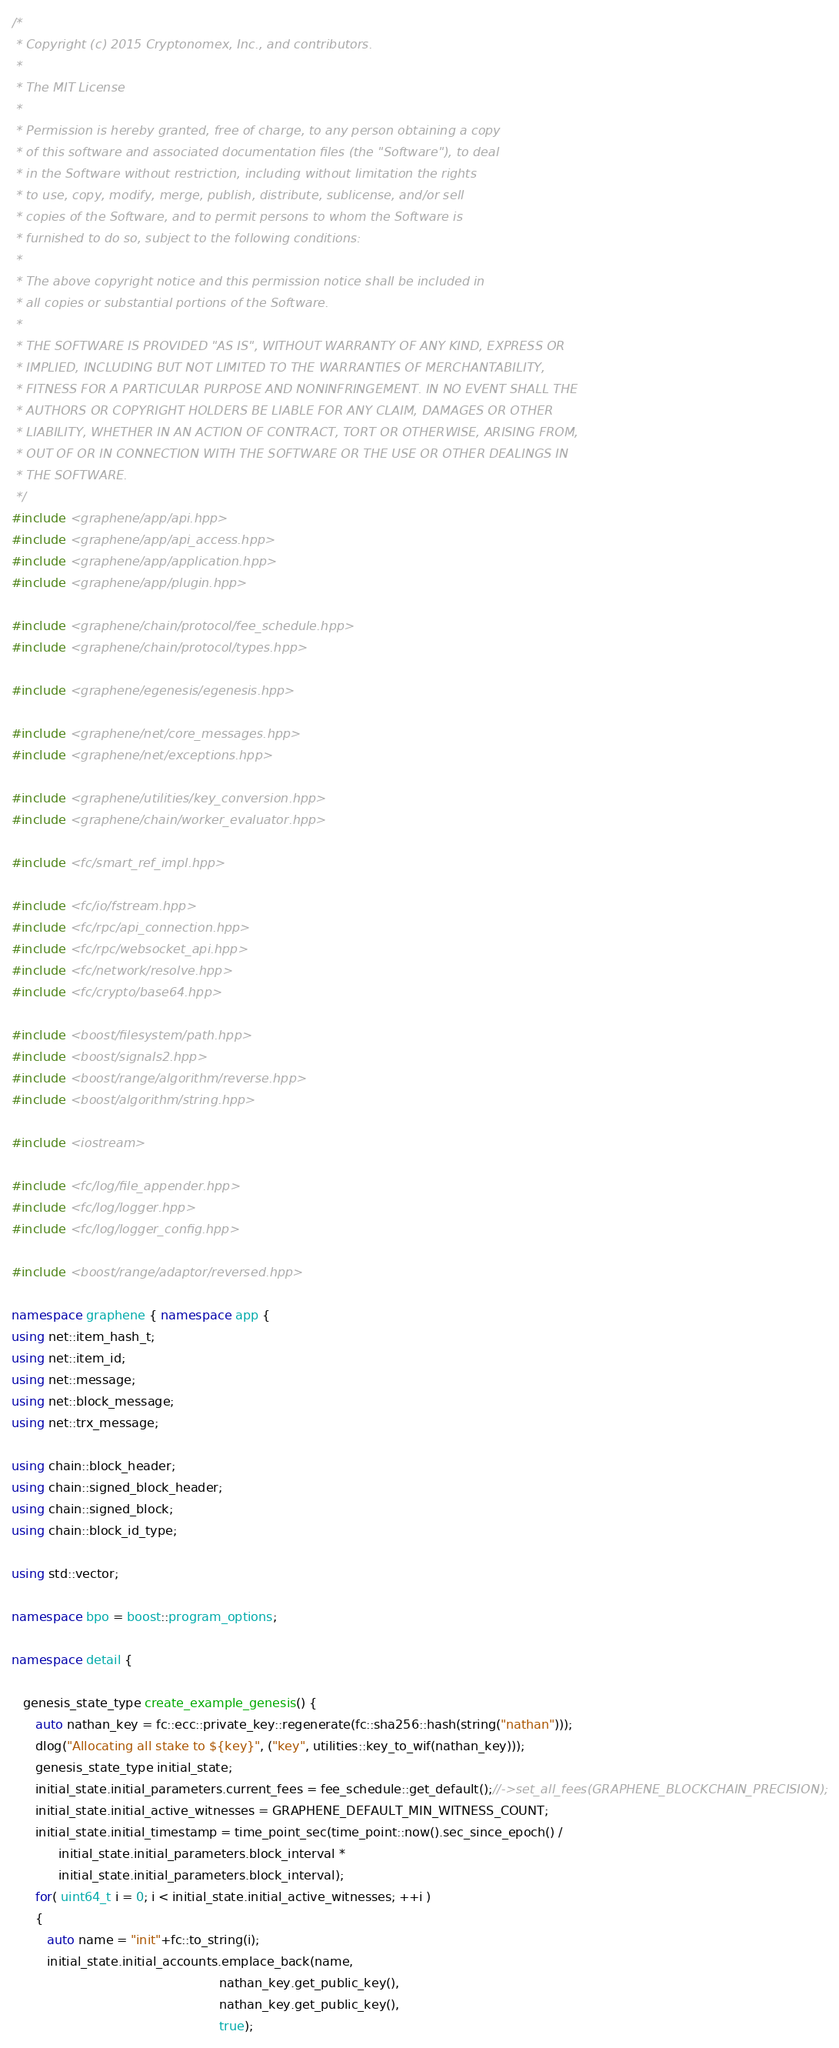Convert code to text. <code><loc_0><loc_0><loc_500><loc_500><_C++_>/*
 * Copyright (c) 2015 Cryptonomex, Inc., and contributors.
 *
 * The MIT License
 *
 * Permission is hereby granted, free of charge, to any person obtaining a copy
 * of this software and associated documentation files (the "Software"), to deal
 * in the Software without restriction, including without limitation the rights
 * to use, copy, modify, merge, publish, distribute, sublicense, and/or sell
 * copies of the Software, and to permit persons to whom the Software is
 * furnished to do so, subject to the following conditions:
 *
 * The above copyright notice and this permission notice shall be included in
 * all copies or substantial portions of the Software.
 *
 * THE SOFTWARE IS PROVIDED "AS IS", WITHOUT WARRANTY OF ANY KIND, EXPRESS OR
 * IMPLIED, INCLUDING BUT NOT LIMITED TO THE WARRANTIES OF MERCHANTABILITY,
 * FITNESS FOR A PARTICULAR PURPOSE AND NONINFRINGEMENT. IN NO EVENT SHALL THE
 * AUTHORS OR COPYRIGHT HOLDERS BE LIABLE FOR ANY CLAIM, DAMAGES OR OTHER
 * LIABILITY, WHETHER IN AN ACTION OF CONTRACT, TORT OR OTHERWISE, ARISING FROM,
 * OUT OF OR IN CONNECTION WITH THE SOFTWARE OR THE USE OR OTHER DEALINGS IN
 * THE SOFTWARE.
 */
#include <graphene/app/api.hpp>
#include <graphene/app/api_access.hpp>
#include <graphene/app/application.hpp>
#include <graphene/app/plugin.hpp>

#include <graphene/chain/protocol/fee_schedule.hpp>
#include <graphene/chain/protocol/types.hpp>

#include <graphene/egenesis/egenesis.hpp>

#include <graphene/net/core_messages.hpp>
#include <graphene/net/exceptions.hpp>

#include <graphene/utilities/key_conversion.hpp>
#include <graphene/chain/worker_evaluator.hpp>

#include <fc/smart_ref_impl.hpp>

#include <fc/io/fstream.hpp>
#include <fc/rpc/api_connection.hpp>
#include <fc/rpc/websocket_api.hpp>
#include <fc/network/resolve.hpp>
#include <fc/crypto/base64.hpp>

#include <boost/filesystem/path.hpp>
#include <boost/signals2.hpp>
#include <boost/range/algorithm/reverse.hpp>
#include <boost/algorithm/string.hpp>

#include <iostream>

#include <fc/log/file_appender.hpp>
#include <fc/log/logger.hpp>
#include <fc/log/logger_config.hpp>

#include <boost/range/adaptor/reversed.hpp>

namespace graphene { namespace app {
using net::item_hash_t;
using net::item_id;
using net::message;
using net::block_message;
using net::trx_message;

using chain::block_header;
using chain::signed_block_header;
using chain::signed_block;
using chain::block_id_type;

using std::vector;

namespace bpo = boost::program_options;

namespace detail {

   genesis_state_type create_example_genesis() {
      auto nathan_key = fc::ecc::private_key::regenerate(fc::sha256::hash(string("nathan")));
      dlog("Allocating all stake to ${key}", ("key", utilities::key_to_wif(nathan_key)));
      genesis_state_type initial_state;
      initial_state.initial_parameters.current_fees = fee_schedule::get_default();//->set_all_fees(GRAPHENE_BLOCKCHAIN_PRECISION);
      initial_state.initial_active_witnesses = GRAPHENE_DEFAULT_MIN_WITNESS_COUNT;
      initial_state.initial_timestamp = time_point_sec(time_point::now().sec_since_epoch() /
            initial_state.initial_parameters.block_interval *
            initial_state.initial_parameters.block_interval);
      for( uint64_t i = 0; i < initial_state.initial_active_witnesses; ++i )
      {
         auto name = "init"+fc::to_string(i);
         initial_state.initial_accounts.emplace_back(name,
                                                     nathan_key.get_public_key(),
                                                     nathan_key.get_public_key(),
                                                     true);</code> 